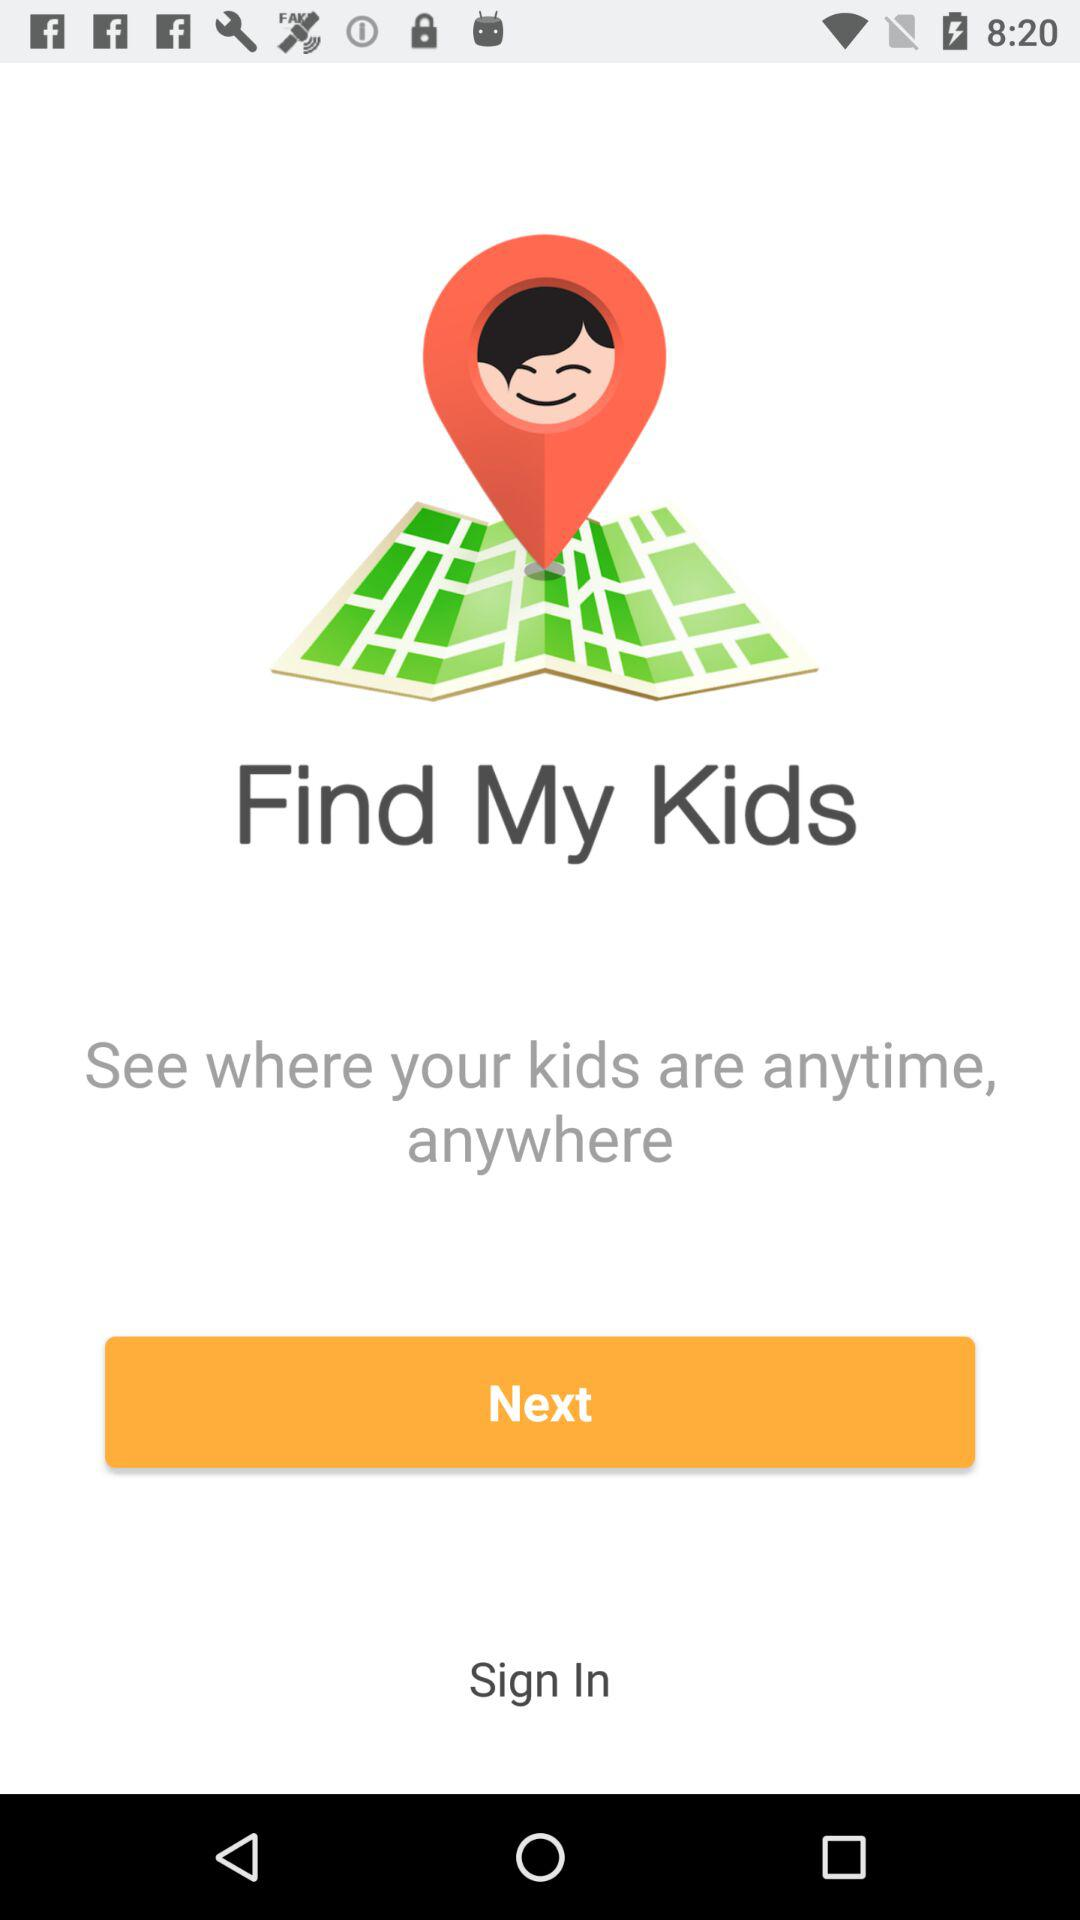What is the application name? The application name is "Find My Kids". 